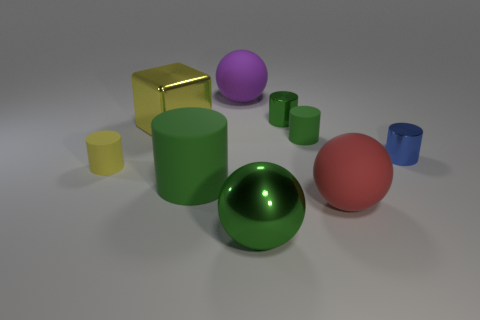The tiny object on the left side of the large green ball is what color?
Keep it short and to the point. Yellow. Are there more tiny matte cylinders behind the green metallic sphere than tiny blue shiny cylinders?
Provide a short and direct response. Yes. Do the green ball and the blue thing have the same material?
Your answer should be very brief. Yes. What number of other objects are there of the same shape as the large yellow object?
Make the answer very short. 0. What is the color of the metal cylinder left of the small shiny object that is in front of the green shiny thing that is behind the green shiny sphere?
Give a very brief answer. Green. Do the large green thing that is in front of the red sphere and the small yellow rubber thing have the same shape?
Offer a very short reply. No. How many small gray metallic objects are there?
Your answer should be compact. 0. What number of other cubes have the same size as the yellow cube?
Give a very brief answer. 0. What material is the large purple sphere?
Give a very brief answer. Rubber. There is a big cylinder; is its color the same as the thing that is in front of the red object?
Keep it short and to the point. Yes. 